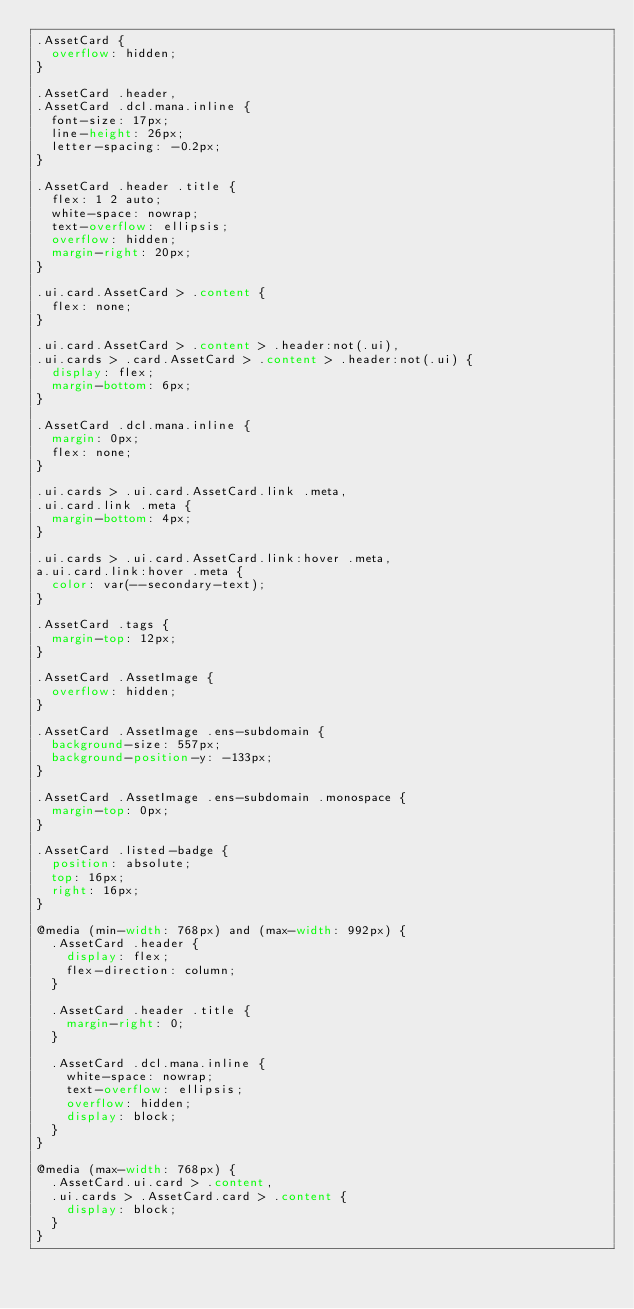Convert code to text. <code><loc_0><loc_0><loc_500><loc_500><_CSS_>.AssetCard {
  overflow: hidden;
}

.AssetCard .header,
.AssetCard .dcl.mana.inline {
  font-size: 17px;
  line-height: 26px;
  letter-spacing: -0.2px;
}

.AssetCard .header .title {
  flex: 1 2 auto;
  white-space: nowrap;
  text-overflow: ellipsis;
  overflow: hidden;
  margin-right: 20px;
}

.ui.card.AssetCard > .content {
  flex: none;
}

.ui.card.AssetCard > .content > .header:not(.ui),
.ui.cards > .card.AssetCard > .content > .header:not(.ui) {
  display: flex;
  margin-bottom: 6px;
}

.AssetCard .dcl.mana.inline {
  margin: 0px;
  flex: none;
}

.ui.cards > .ui.card.AssetCard.link .meta,
.ui.card.link .meta {
  margin-bottom: 4px;
}

.ui.cards > .ui.card.AssetCard.link:hover .meta,
a.ui.card.link:hover .meta {
  color: var(--secondary-text);
}

.AssetCard .tags {
  margin-top: 12px;
}

.AssetCard .AssetImage {
  overflow: hidden;
}

.AssetCard .AssetImage .ens-subdomain {
  background-size: 557px;
  background-position-y: -133px;
}

.AssetCard .AssetImage .ens-subdomain .monospace {
  margin-top: 0px;
}

.AssetCard .listed-badge {
  position: absolute;
  top: 16px;
  right: 16px;
}

@media (min-width: 768px) and (max-width: 992px) {
  .AssetCard .header {
    display: flex;
    flex-direction: column;
  }

  .AssetCard .header .title {
    margin-right: 0;
  }

  .AssetCard .dcl.mana.inline {
    white-space: nowrap;
    text-overflow: ellipsis;
    overflow: hidden;
    display: block;
  }
}

@media (max-width: 768px) {
  .AssetCard.ui.card > .content,
  .ui.cards > .AssetCard.card > .content {
    display: block;
  }
}
</code> 